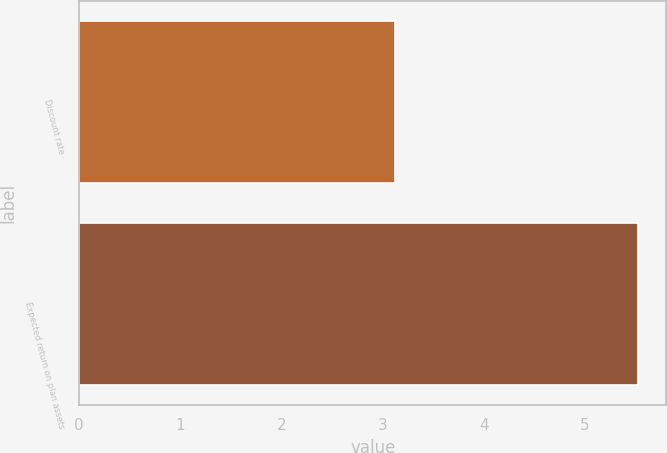Convert chart to OTSL. <chart><loc_0><loc_0><loc_500><loc_500><bar_chart><fcel>Discount rate<fcel>Expected return on plan assets<nl><fcel>3.12<fcel>5.53<nl></chart> 